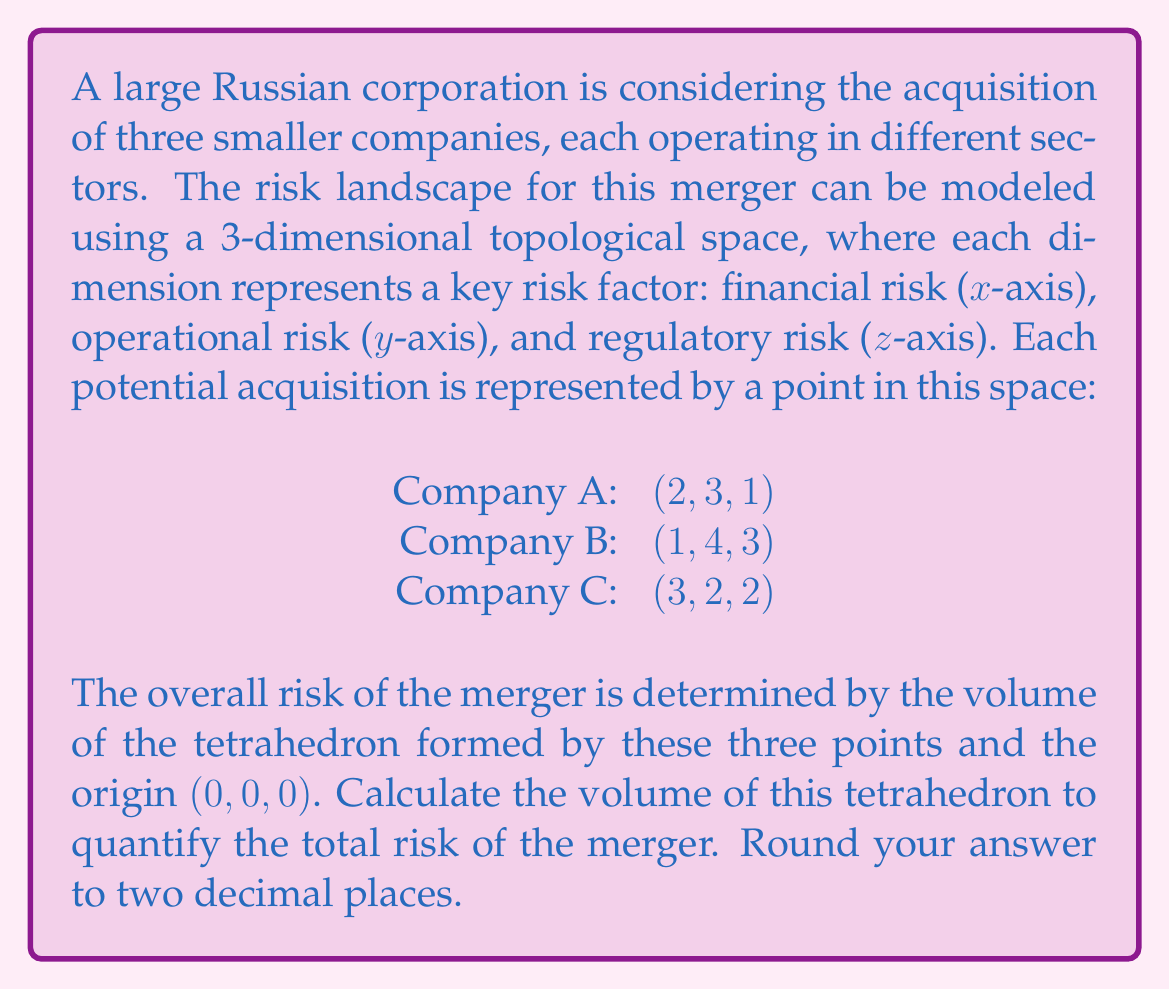Could you help me with this problem? To solve this problem, we need to follow these steps:

1) The volume of a tetrahedron can be calculated using the formula:

   $$V = \frac{1}{6}|det(a-d, b-d, c-d)|$$

   where a, b, c are the coordinates of three vertices, and d is the fourth vertex (in this case, the origin).

2) Let's set up our matrix:

   $$\begin{vmatrix}
   2-0 & 1-0 & 3-0 \\
   3-0 & 4-0 & 2-0 \\
   1-0 & 3-0 & 2-0
   \end{vmatrix}$$

   Which simplifies to:

   $$\begin{vmatrix}
   2 & 1 & 3 \\
   3 & 4 & 2 \\
   1 & 3 & 2
   \end{vmatrix}$$

3) Now we need to calculate the determinant of this 3x3 matrix:

   $det = 2(4\cdot2 - 3\cdot2) - 1(3\cdot2 - 1\cdot2) + 3(3\cdot1 - 4\cdot1)$
   
   $    = 2(8 - 6) - 1(6 - 2) + 3(3 - 4)$
   
   $    = 2(2) - 1(4) + 3(-1)$
   
   $    = 4 - 4 - 3$
   
   $    = -3$

4) The volume is the absolute value of this determinant divided by 6:

   $$V = \frac{1}{6}|-3| = \frac{1}{6}(3) = 0.5$$

5) Therefore, the volume of the tetrahedron, representing the total risk of the merger, is 0.50 (rounded to two decimal places).
Answer: 0.50 